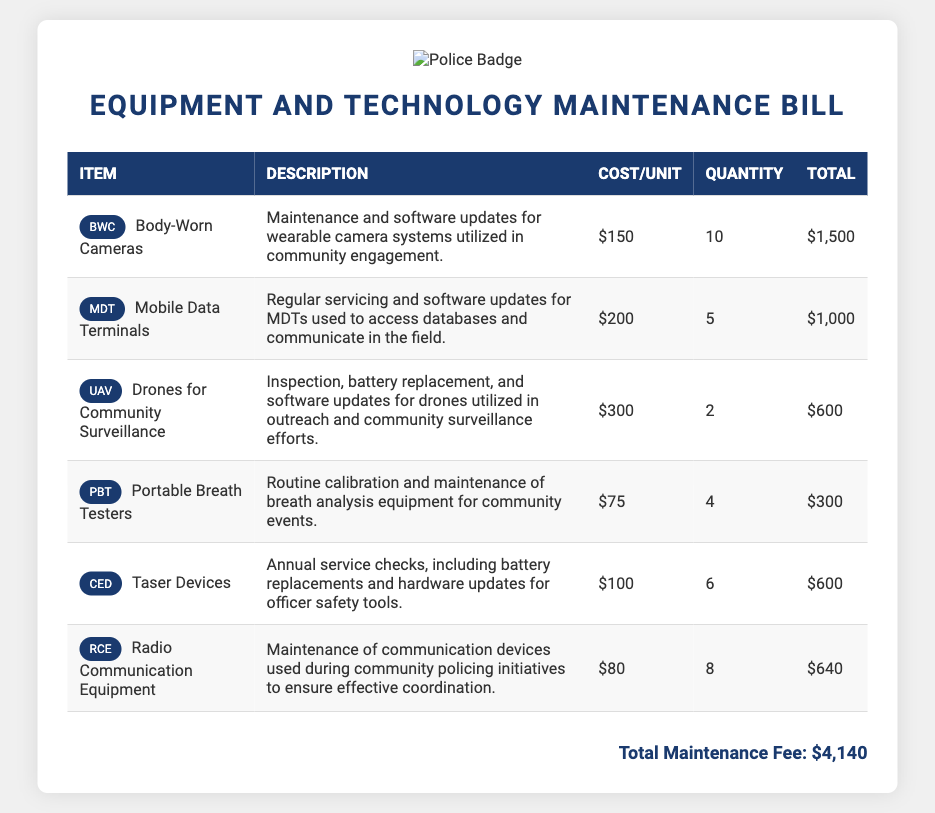What is the total maintenance fee? The total maintenance fee is provided at the end of the document, which is $4,140.
Answer: $4,140 How many Body-Worn Cameras are being maintained? The quantity of Body-Worn Cameras is specified in the document as 10.
Answer: 10 What is the cost per unit for Mobile Data Terminals? The cost per unit for Mobile Data Terminals is indicated as $200.
Answer: $200 Which item has the highest maintenance cost per unit? By comparing the costs per unit listed, the item with the highest cost is Drones for Community Surveillance at $300.
Answer: Drones for Community Surveillance What type of equipment is maintained for officer safety? The document specifies that Taser Devices are maintained for officer safety.
Answer: Taser Devices How many Portable Breath Testers require maintenance? The number of Portable Breath Testers specified in the maintenance bill is 4.
Answer: 4 What is the description for Radio Communication Equipment maintenance? The description indicates that it is for maintenance of communication devices used during community policing initiatives.
Answer: Maintenance of communication devices used during community policing initiatives Which item has the lowest total maintenance cost? By reviewing the totals, the item with the lowest total maintenance cost is Portable Breath Testers at $300.
Answer: Portable Breath Testers 